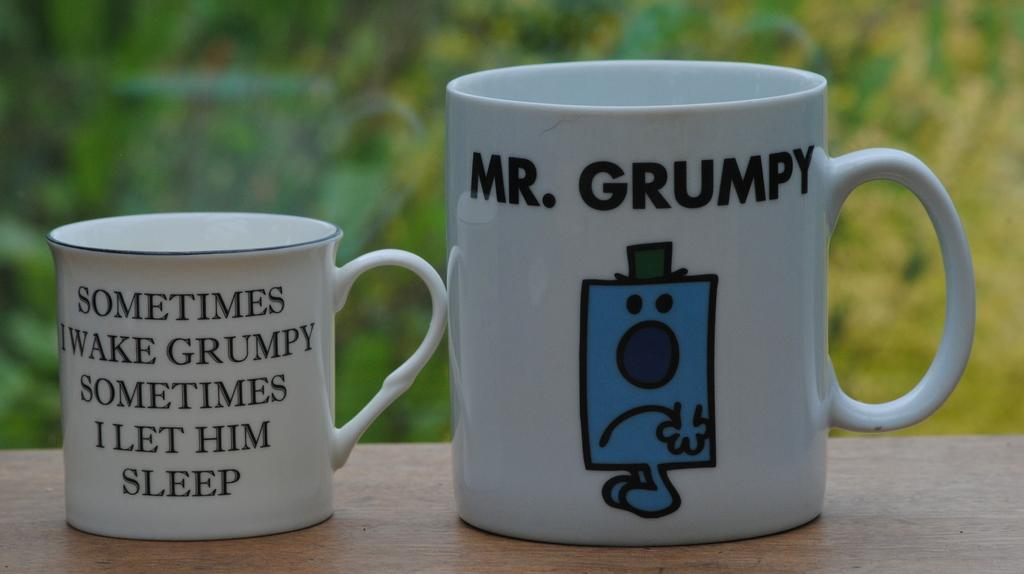<image>
Summarize the visual content of the image. Two coffee cups with funny messages about being grumpy 